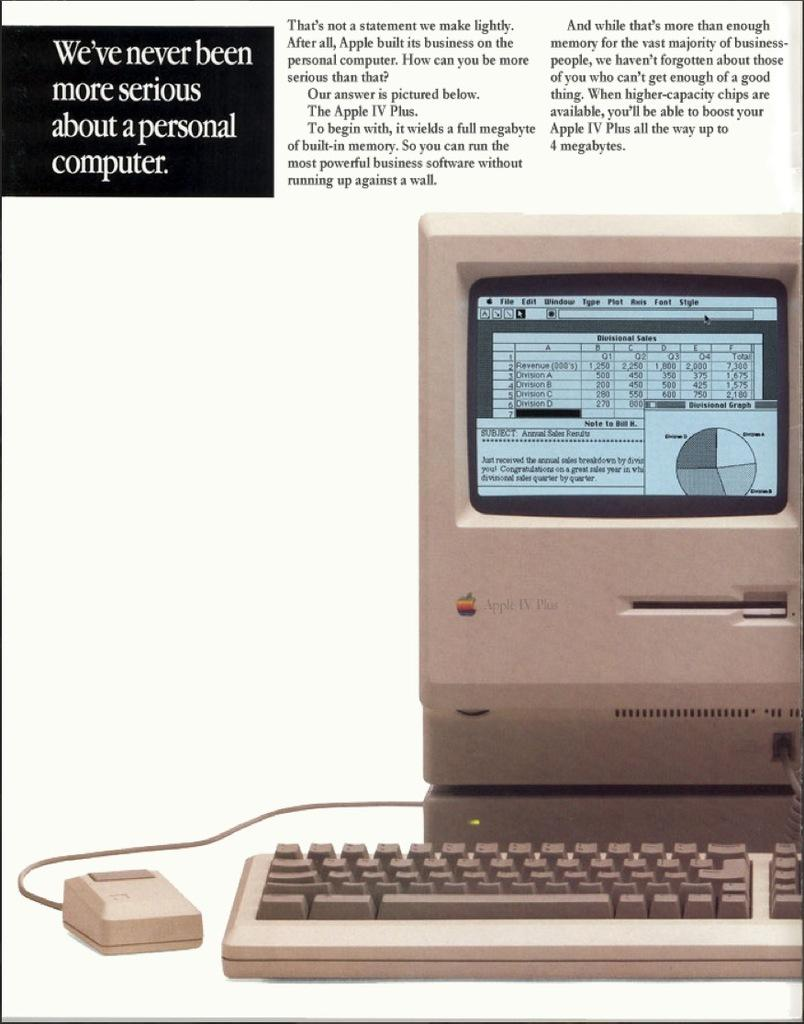<image>
Share a concise interpretation of the image provided. A ad for an old fashioned computer with the slogan 'we've never been more serious about a personal computer' 